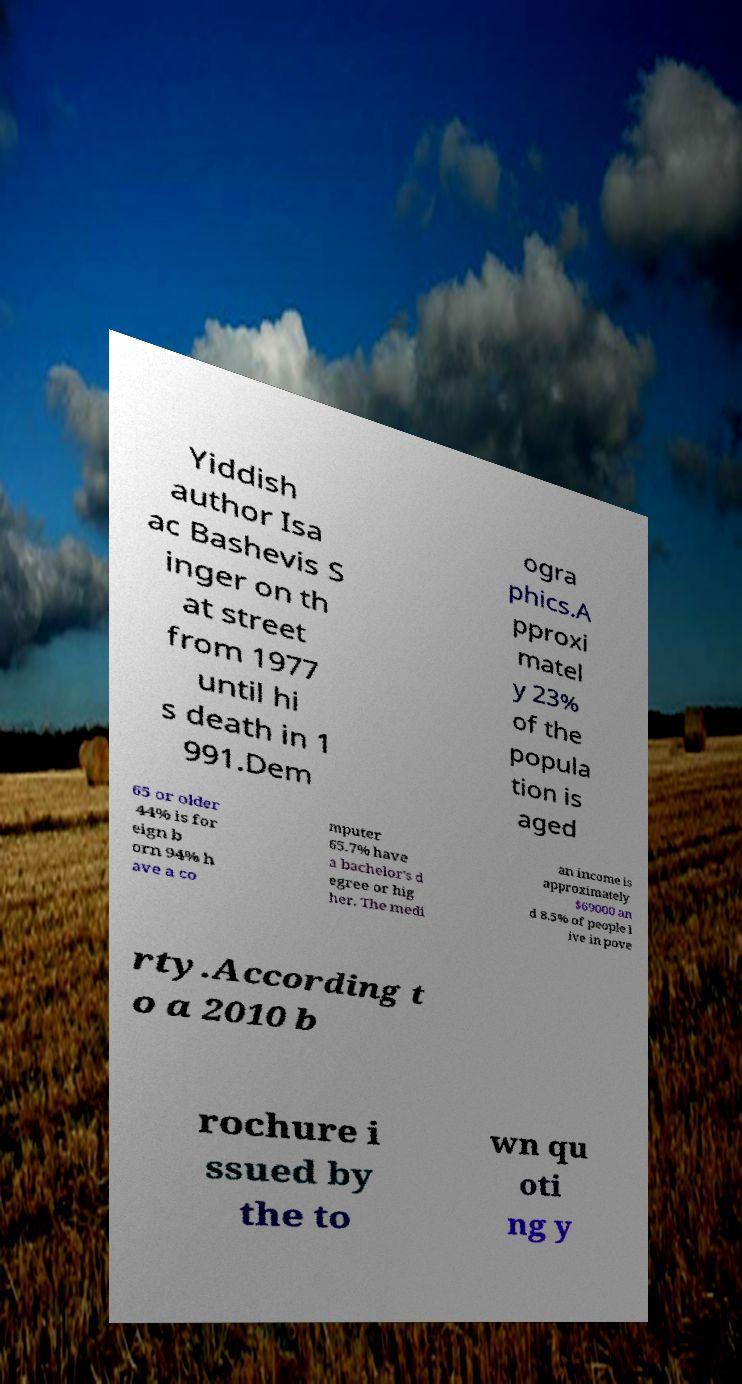For documentation purposes, I need the text within this image transcribed. Could you provide that? Yiddish author Isa ac Bashevis S inger on th at street from 1977 until hi s death in 1 991.Dem ogra phics.A pproxi matel y 23% of the popula tion is aged 65 or older 44% is for eign b orn 94% h ave a co mputer 65.7% have a bachelor's d egree or hig her. The medi an income is approximately $69000 an d 8.5% of people l ive in pove rty.According t o a 2010 b rochure i ssued by the to wn qu oti ng y 